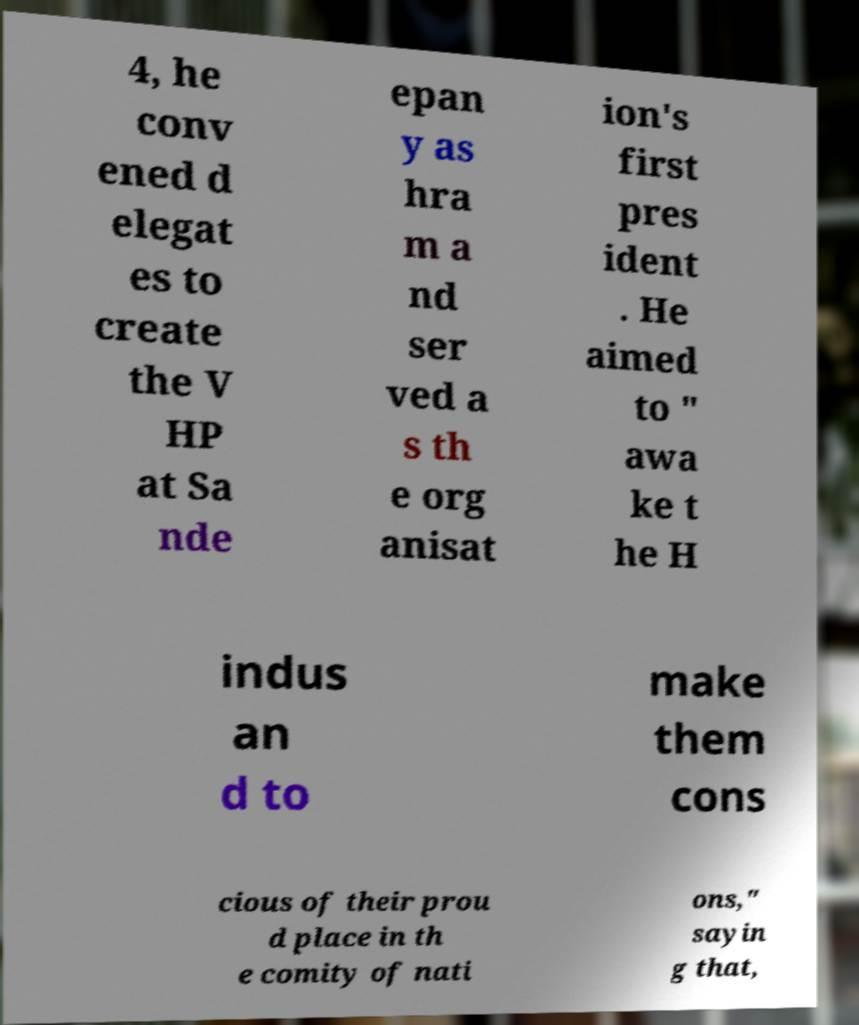Can you read and provide the text displayed in the image?This photo seems to have some interesting text. Can you extract and type it out for me? 4, he conv ened d elegat es to create the V HP at Sa nde epan y as hra m a nd ser ved a s th e org anisat ion's first pres ident . He aimed to " awa ke t he H indus an d to make them cons cious of their prou d place in th e comity of nati ons," sayin g that, 